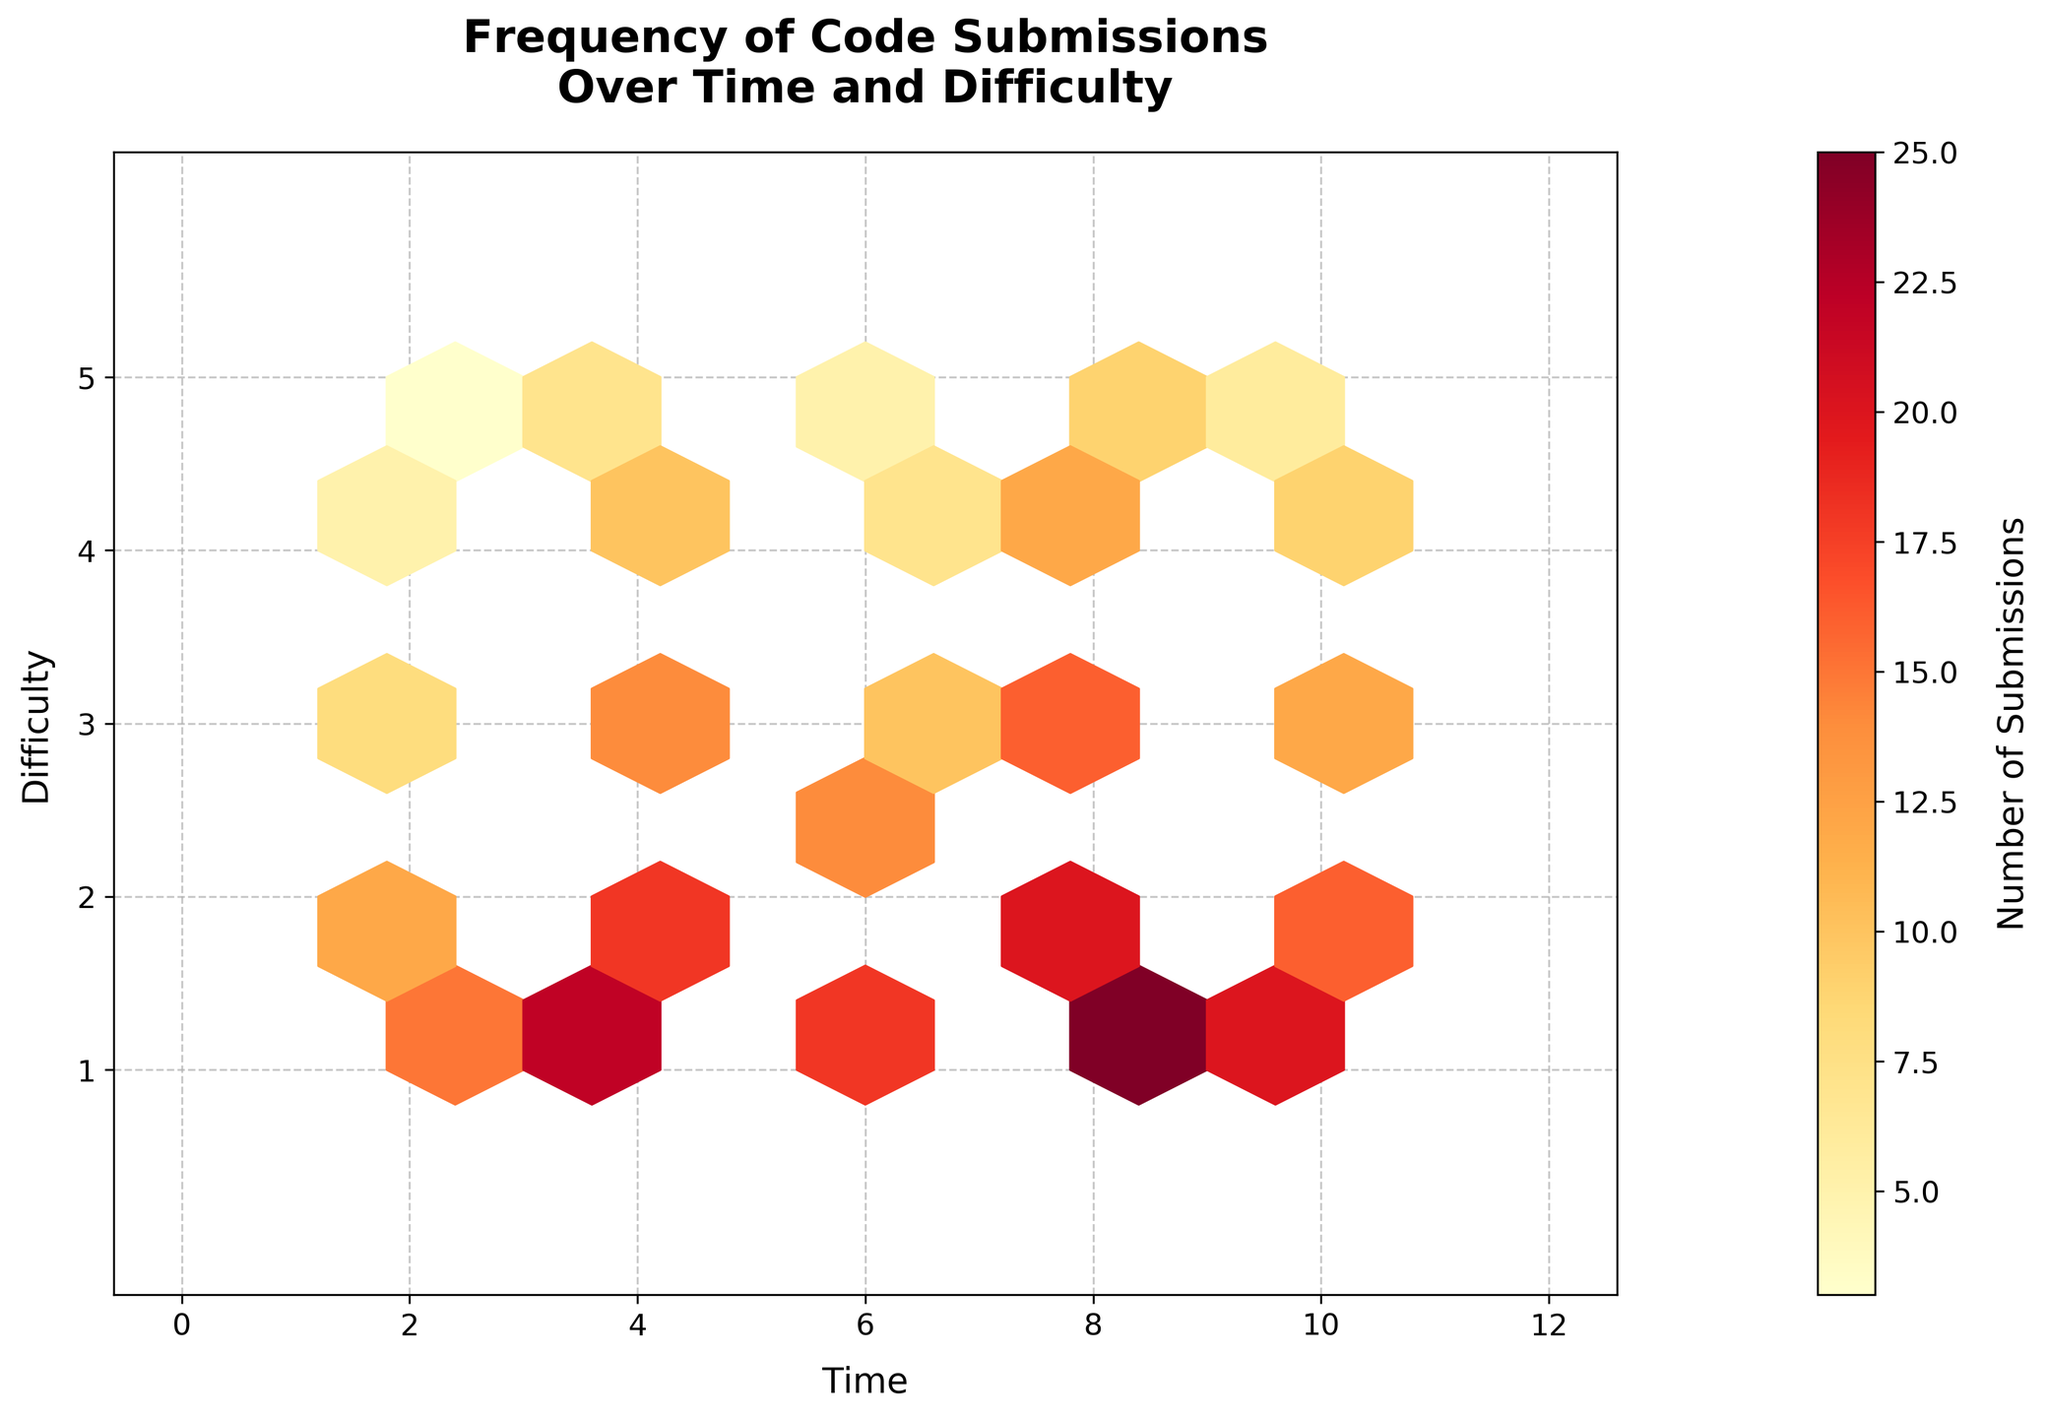What is the title of the plot? The title is text that usually appears at the top of a plot, summarizing what it represents. In this plot, it reads "Frequency of Code Submissions Over Time and Difficulty".
Answer: Frequency of Code Submissions Over Time and Difficulty What is used to represent the number of submissions in the plot? In the hexbin plot, the color intensity of each hexagon represents the number of submissions. This is shown using a color map where colors range from yellow to red corresponding to submission counts.
Answer: Color intensity What are the labels of the x-axis and y-axis? The x-axis and y-axis are labeled to indicate what they represent. The x-axis is labeled "Time" and the y-axis is labeled "Difficulty".
Answer: Time (x-axis) and Difficulty (y-axis) How are the color gradients on the hexagons interpreted? The color gradients in the hexagons in a hexbin plot represent frequency. Lighter colors (yellow) indicate fewer submissions, while darker colors (red) indicate more submissions.
Answer: Lighter colors indicate fewer submissions; darker colors indicate more Between which time intervals is the frequency of submissions the highest for difficulty level 2? Look for the hexagons that correspond to difficulty level 2 and identify the one with the darkest color. The darkest hexagon is between time intervals 6 and 8.
Answer: Between 6 and 8 Which difficulty level shows the most significant increase in submissions over time? By observing the color intensity of hexagons over time, it appears that difficulty level 1 shows the most significant increase, transitioning from lighter to much darker hexagons.
Answer: Difficulty level 1 What is the grid size used in the hexbin plot? The grid size in a hexbin plot specifies the number of hexagons along each axis. In this plot, the grid size used is 10, as can be inferred from the number and arrangement of the hexagons.
Answer: 10 How does the number of submissions change for difficulty level 4 between time 2 and time 8? At difficulty level 4, observe the color intensity progression at times 2, 4, 6, and 8. The number of submissions increases steadily as indicated by the darkening color of the hexagons.
Answer: The number of submissions increases Which time interval has the least variation in submission frequencies across all difficulty levels? Compare the range of colors for each time interval across all difficulty levels. The time interval 2 to 4 shows the least variation, with mostly lighter hexagons.
Answer: Time interval 2 to 4 At which difficulty level is the submission frequency consistently low over time? Look for consistently lighter hexagons across time for a particular difficulty level. Difficulty level 5 has consistently lighter colors, indicating a consistently low frequency of submissions.
Answer: Difficulty level 5 